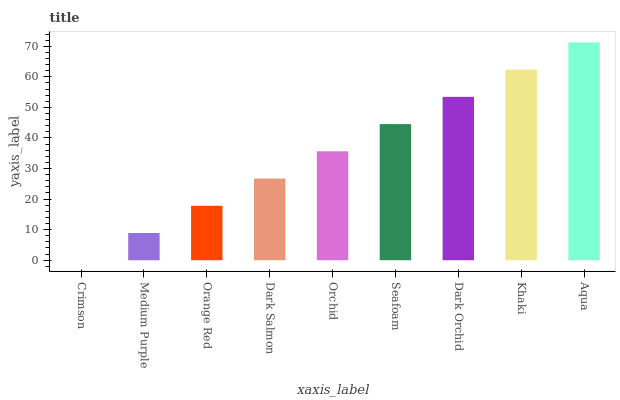Is Crimson the minimum?
Answer yes or no. Yes. Is Aqua the maximum?
Answer yes or no. Yes. Is Medium Purple the minimum?
Answer yes or no. No. Is Medium Purple the maximum?
Answer yes or no. No. Is Medium Purple greater than Crimson?
Answer yes or no. Yes. Is Crimson less than Medium Purple?
Answer yes or no. Yes. Is Crimson greater than Medium Purple?
Answer yes or no. No. Is Medium Purple less than Crimson?
Answer yes or no. No. Is Orchid the high median?
Answer yes or no. Yes. Is Orchid the low median?
Answer yes or no. Yes. Is Khaki the high median?
Answer yes or no. No. Is Dark Salmon the low median?
Answer yes or no. No. 